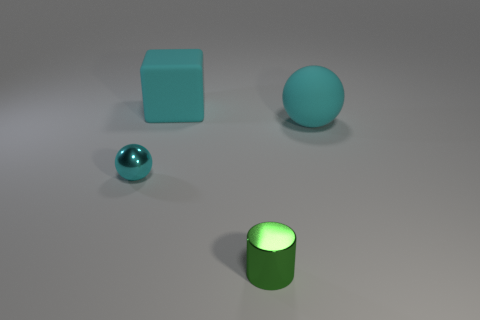What material is the tiny sphere that is the same color as the large block?
Ensure brevity in your answer.  Metal. How many other cyan matte objects have the same shape as the tiny cyan object?
Offer a terse response. 1. There is a large object to the left of the cylinder; is its color the same as the sphere that is behind the cyan metallic sphere?
Your response must be concise. Yes. There is a sphere that is the same size as the cylinder; what is it made of?
Offer a terse response. Metal. Are there any red metal cubes that have the same size as the cyan cube?
Offer a terse response. No. Is the number of green shiny objects left of the cyan metal sphere less than the number of balls?
Your answer should be very brief. Yes. Are there fewer big matte objects that are to the left of the cyan metal sphere than small cylinders in front of the large cyan sphere?
Provide a succinct answer. Yes. What number of spheres are either tiny things or big cyan objects?
Offer a very short reply. 2. Is the object in front of the small cyan metallic object made of the same material as the small cyan thing left of the tiny green thing?
Keep it short and to the point. Yes. There is a green object that is the same size as the cyan metallic thing; what shape is it?
Make the answer very short. Cylinder. 